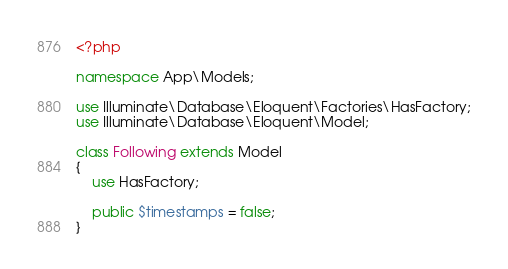Convert code to text. <code><loc_0><loc_0><loc_500><loc_500><_PHP_><?php

namespace App\Models;

use Illuminate\Database\Eloquent\Factories\HasFactory;
use Illuminate\Database\Eloquent\Model;

class Following extends Model
{
    use HasFactory;

    public $timestamps = false;
}
</code> 